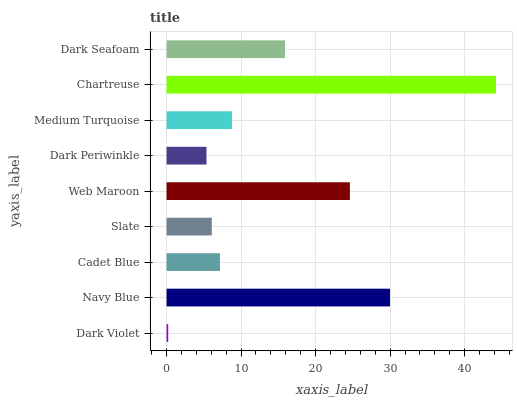Is Dark Violet the minimum?
Answer yes or no. Yes. Is Chartreuse the maximum?
Answer yes or no. Yes. Is Navy Blue the minimum?
Answer yes or no. No. Is Navy Blue the maximum?
Answer yes or no. No. Is Navy Blue greater than Dark Violet?
Answer yes or no. Yes. Is Dark Violet less than Navy Blue?
Answer yes or no. Yes. Is Dark Violet greater than Navy Blue?
Answer yes or no. No. Is Navy Blue less than Dark Violet?
Answer yes or no. No. Is Medium Turquoise the high median?
Answer yes or no. Yes. Is Medium Turquoise the low median?
Answer yes or no. Yes. Is Web Maroon the high median?
Answer yes or no. No. Is Cadet Blue the low median?
Answer yes or no. No. 